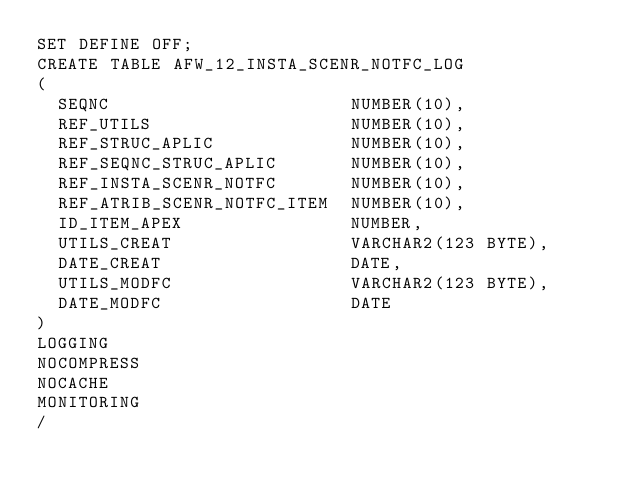<code> <loc_0><loc_0><loc_500><loc_500><_SQL_>SET DEFINE OFF;
CREATE TABLE AFW_12_INSTA_SCENR_NOTFC_LOG
(
  SEQNC                       NUMBER(10),
  REF_UTILS                   NUMBER(10),
  REF_STRUC_APLIC             NUMBER(10),
  REF_SEQNC_STRUC_APLIC       NUMBER(10),
  REF_INSTA_SCENR_NOTFC       NUMBER(10),
  REF_ATRIB_SCENR_NOTFC_ITEM  NUMBER(10),
  ID_ITEM_APEX                NUMBER,
  UTILS_CREAT                 VARCHAR2(123 BYTE),
  DATE_CREAT                  DATE,
  UTILS_MODFC                 VARCHAR2(123 BYTE),
  DATE_MODFC                  DATE
)
LOGGING 
NOCOMPRESS 
NOCACHE
MONITORING
/
</code> 